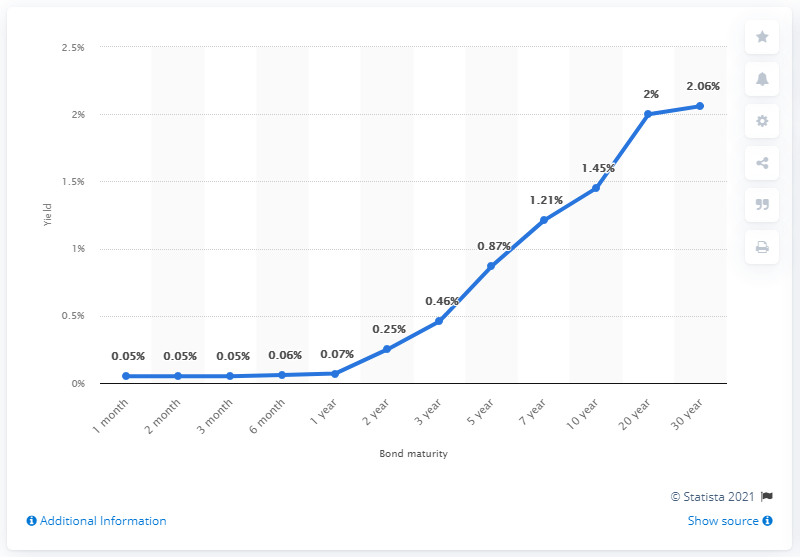Specify some key components in this picture. On June 2021, the yield for a ten-year U.S. government bond was 1.45%. The maximum treasury yield bond maturity is different from the minimum yield bond maturity, with a difference of 2.01. The treasury yield on a 3-year bond maturity is 0.46%. As of June 2021, the yield for a two-year U.S. government bond was 0.25%. As of June 2021, the yield for a two-year U.S. government bond was 0.25%. 